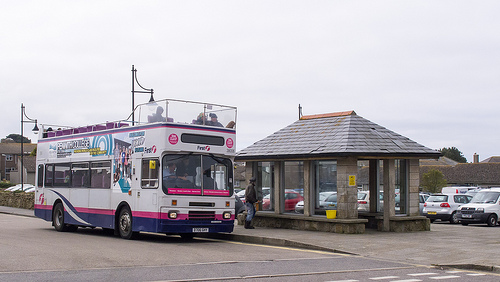Who is the vehicle near the man carrying? The vehicle near the man is carrying people. 